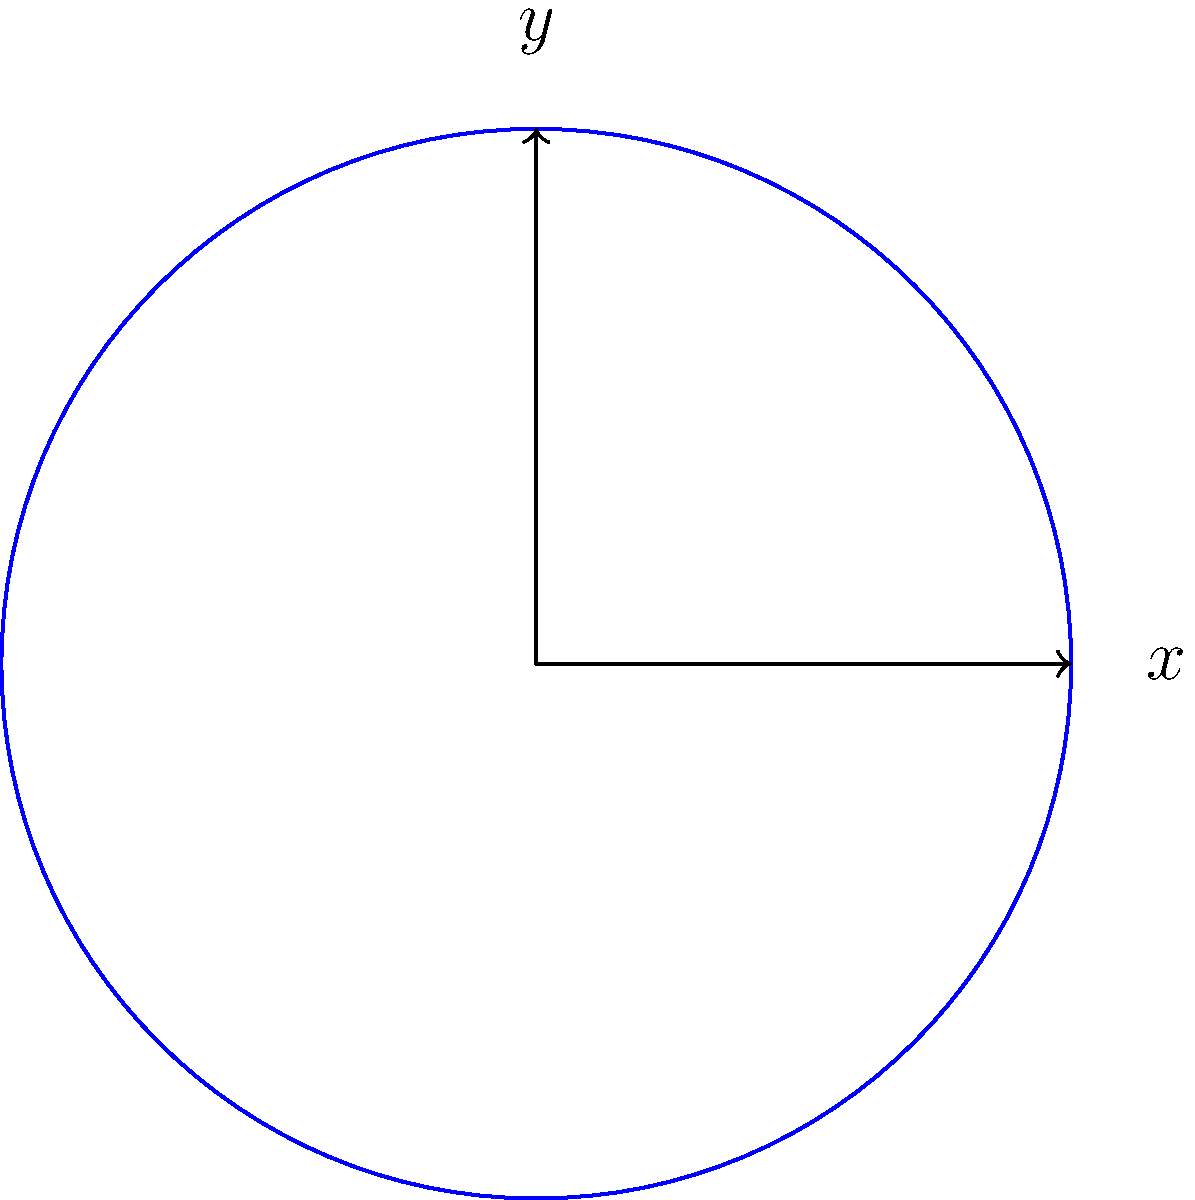In a historical battle formation from the 18th century, eight soldiers are positioned in a circular arrangement around a central point. The positions of the soldiers can be represented using polar coordinates $(r, \theta)$, where $r = 1$ (unit circle) and $\theta$ is measured counterclockwise from the positive x-axis. If soldier $S_1$ is at $(1, 0°)$ and the rest are equally spaced, what are the polar coordinates of soldier $S_5$? To solve this problem, we need to follow these steps:

1) First, we need to understand the arrangement:
   - There are 8 soldiers equally spaced around a circle.
   - They are on a unit circle, so $r = 1$ for all soldiers.
   - $S_1$ is at 0°, which is the starting point on the positive x-axis.

2) Calculate the angle between each soldier:
   - Total angle of a circle = 360°
   - Number of soldiers = 8
   - Angle between each soldier = 360° ÷ 8 = 45°

3) Find the position of $S_5$:
   - $S_5$ is 4 positions away from $S_1$ (counting $S_1$ as the first position)
   - Angle for $S_5$ = 4 × 45° = 180°

4) Express the position in polar coordinates:
   - $r = 1$ (as given, unit circle)
   - $\theta = 180°$

Therefore, the polar coordinates of soldier $S_5$ are $(1, 180°)$.
Answer: $(1, 180°)$ 